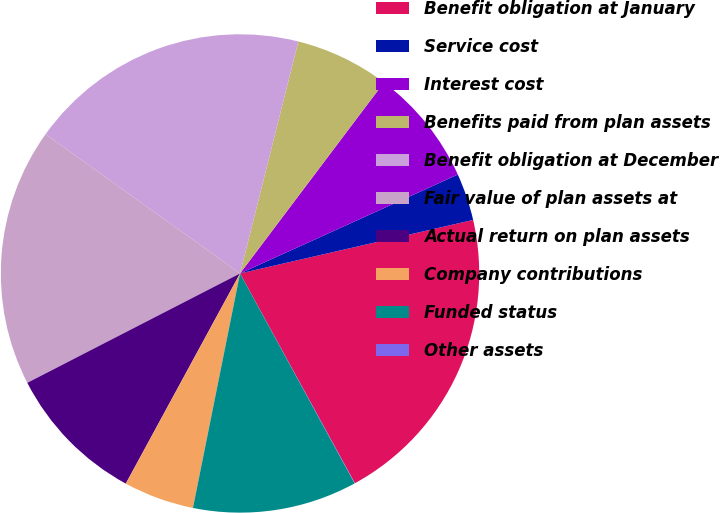<chart> <loc_0><loc_0><loc_500><loc_500><pie_chart><fcel>Benefit obligation at January<fcel>Service cost<fcel>Interest cost<fcel>Benefits paid from plan assets<fcel>Benefit obligation at December<fcel>Fair value of plan assets at<fcel>Actual return on plan assets<fcel>Company contributions<fcel>Funded status<fcel>Other assets<nl><fcel>20.62%<fcel>3.19%<fcel>7.94%<fcel>6.36%<fcel>19.03%<fcel>17.45%<fcel>9.52%<fcel>4.77%<fcel>11.11%<fcel>0.02%<nl></chart> 